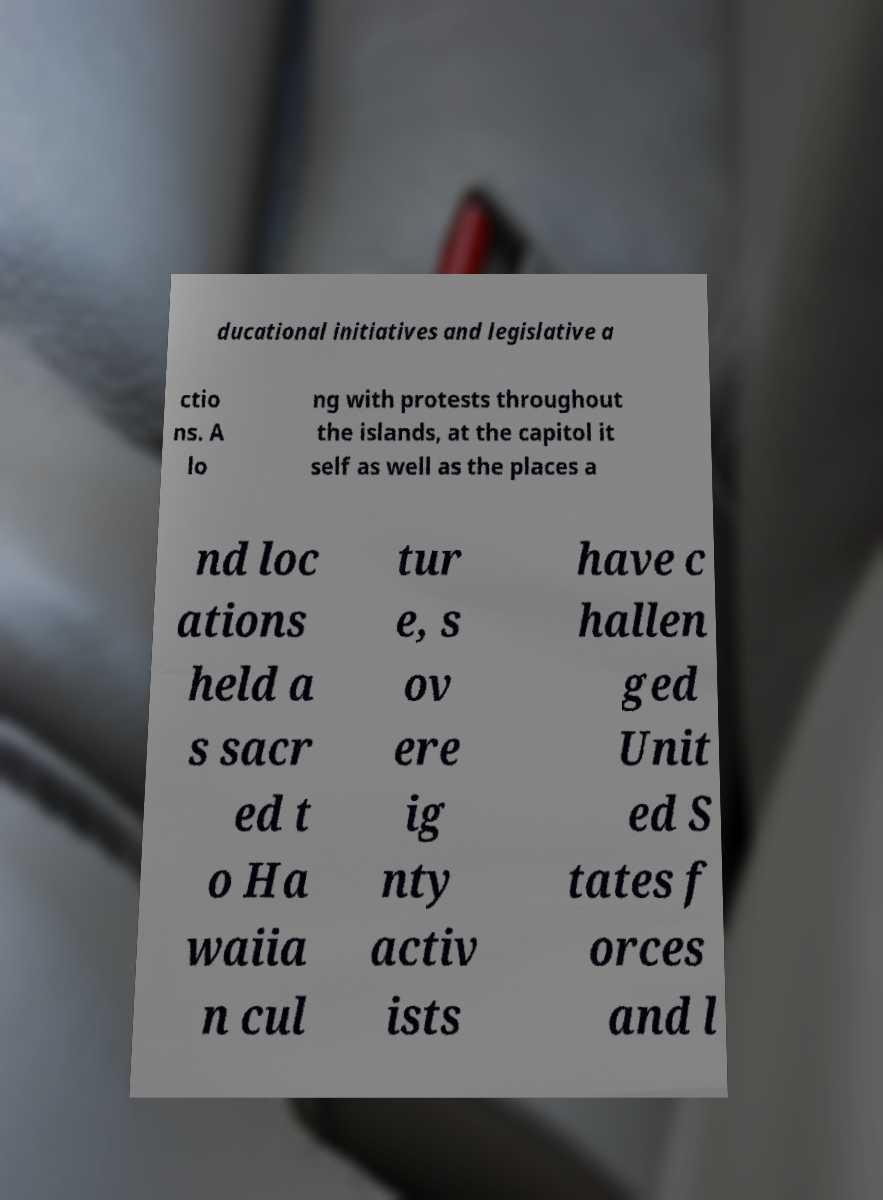Can you read and provide the text displayed in the image?This photo seems to have some interesting text. Can you extract and type it out for me? ducational initiatives and legislative a ctio ns. A lo ng with protests throughout the islands, at the capitol it self as well as the places a nd loc ations held a s sacr ed t o Ha waiia n cul tur e, s ov ere ig nty activ ists have c hallen ged Unit ed S tates f orces and l 